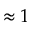<formula> <loc_0><loc_0><loc_500><loc_500>\approx 1</formula> 